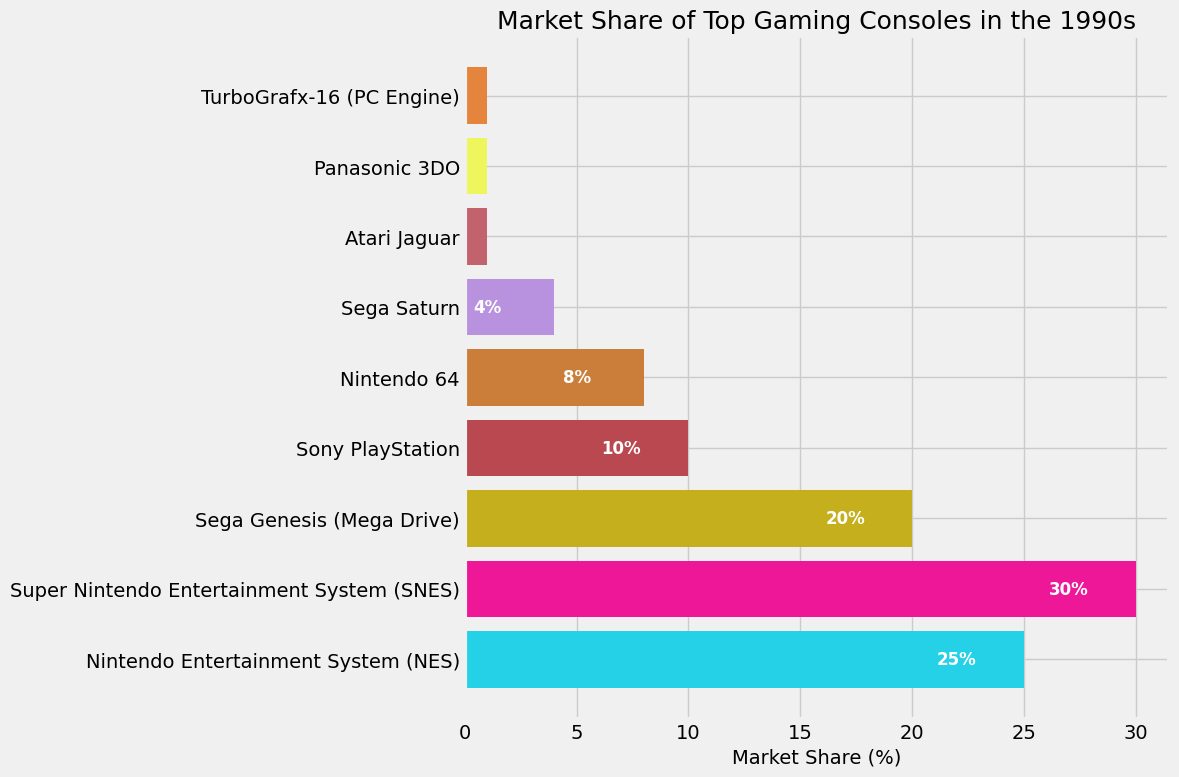What's the gaming console with the highest market share in the 1990s? The bar chart shows various gaming consoles and their respective market shares. By looking at the length of the bars, the Super Nintendo Entertainment System (SNES) has the longest bar, indicating it has the highest market share.
Answer: Super Nintendo Entertainment System (SNES) How much more market share does Super Nintendo Entertainment System (SNES) have compared to Sega Genesis (Mega Drive)? To find the difference in market share between SNES and Sega Genesis, subtract the market share of Sega Genesis from that of SNES. SNES has 30% market share and Sega Genesis has 20%, so the difference is 30% - 20%.
Answer: 10% Which two gaming consoles have the smallest market share and what are their combined market shares? By checking the shortest bars on the chart, Atari Jaguar, Panasonic 3DO, and TurboGrafx-16 (PC Engine) each have the smallest market share, which is 1%. Adding them together, the combined market share is 1% + 1% + 1%.
Answer: 3% What is the combined market share of all Nintendo consoles shown in the figure? The chart lists Nintendo Entertainment System (NES) with 25%, Super Nintendo Entertainment System (SNES) with 30%, and Nintendo 64 with 8%. Summing these together gives 25% + 30% + 8%.
Answer: 63% How does the market share of Sony PlayStation compare to that of Nintendo 64? Looking at the bars for Sony PlayStation and Nintendo 64, Sony PlayStation has a market share of 10% while Nintendo 64 has a market share of 8%. Therefore, Sony PlayStation has a higher market share.
Answer: Sony PlayStation What is the total market share for Sega consoles shown in the figure? The chart includes Sega Genesis (Mega Drive) with 20% and Sega Saturn with 4%. Adding these together gives 20% + 4%.
Answer: 24% Which console has a market share half that of Nintendo Entertainment System (NES)? NES has a market share of 25%. Half of 25% is 12.5%. By checking the chart, no console has exactly 12.5%, but none is closest to having a market share close to this value.
Answer: None 